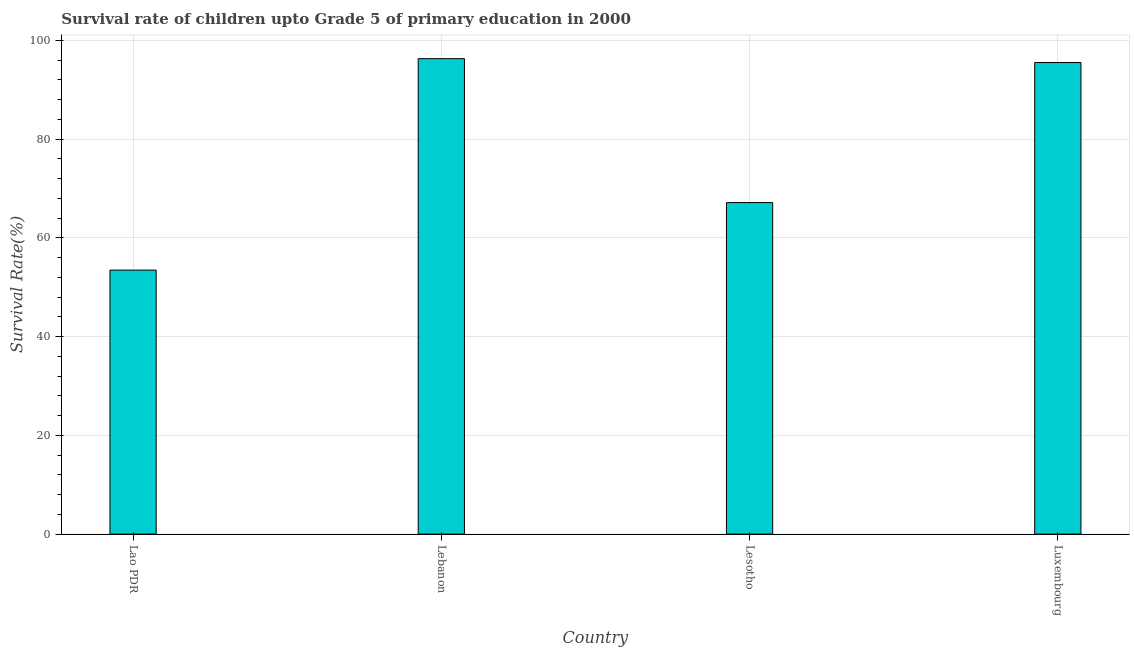Does the graph contain any zero values?
Provide a short and direct response. No. What is the title of the graph?
Provide a succinct answer. Survival rate of children upto Grade 5 of primary education in 2000 . What is the label or title of the X-axis?
Your answer should be very brief. Country. What is the label or title of the Y-axis?
Provide a short and direct response. Survival Rate(%). What is the survival rate in Lebanon?
Give a very brief answer. 96.32. Across all countries, what is the maximum survival rate?
Make the answer very short. 96.32. Across all countries, what is the minimum survival rate?
Offer a very short reply. 53.48. In which country was the survival rate maximum?
Provide a short and direct response. Lebanon. In which country was the survival rate minimum?
Offer a very short reply. Lao PDR. What is the sum of the survival rate?
Ensure brevity in your answer.  312.49. What is the difference between the survival rate in Lao PDR and Lebanon?
Keep it short and to the point. -42.84. What is the average survival rate per country?
Offer a very short reply. 78.12. What is the median survival rate?
Your answer should be very brief. 81.35. In how many countries, is the survival rate greater than 4 %?
Your answer should be compact. 4. What is the ratio of the survival rate in Lao PDR to that in Luxembourg?
Your response must be concise. 0.56. Is the difference between the survival rate in Lao PDR and Luxembourg greater than the difference between any two countries?
Your answer should be compact. No. What is the difference between the highest and the second highest survival rate?
Provide a succinct answer. 0.79. Is the sum of the survival rate in Lesotho and Luxembourg greater than the maximum survival rate across all countries?
Provide a succinct answer. Yes. What is the difference between the highest and the lowest survival rate?
Your response must be concise. 42.84. How many bars are there?
Offer a terse response. 4. Are all the bars in the graph horizontal?
Provide a short and direct response. No. How many countries are there in the graph?
Your answer should be very brief. 4. What is the difference between two consecutive major ticks on the Y-axis?
Your answer should be very brief. 20. Are the values on the major ticks of Y-axis written in scientific E-notation?
Your response must be concise. No. What is the Survival Rate(%) of Lao PDR?
Keep it short and to the point. 53.48. What is the Survival Rate(%) in Lebanon?
Your answer should be very brief. 96.32. What is the Survival Rate(%) in Lesotho?
Your response must be concise. 67.16. What is the Survival Rate(%) of Luxembourg?
Offer a terse response. 95.53. What is the difference between the Survival Rate(%) in Lao PDR and Lebanon?
Make the answer very short. -42.84. What is the difference between the Survival Rate(%) in Lao PDR and Lesotho?
Your answer should be compact. -13.68. What is the difference between the Survival Rate(%) in Lao PDR and Luxembourg?
Give a very brief answer. -42.06. What is the difference between the Survival Rate(%) in Lebanon and Lesotho?
Ensure brevity in your answer.  29.16. What is the difference between the Survival Rate(%) in Lebanon and Luxembourg?
Ensure brevity in your answer.  0.79. What is the difference between the Survival Rate(%) in Lesotho and Luxembourg?
Make the answer very short. -28.37. What is the ratio of the Survival Rate(%) in Lao PDR to that in Lebanon?
Offer a very short reply. 0.56. What is the ratio of the Survival Rate(%) in Lao PDR to that in Lesotho?
Offer a very short reply. 0.8. What is the ratio of the Survival Rate(%) in Lao PDR to that in Luxembourg?
Offer a terse response. 0.56. What is the ratio of the Survival Rate(%) in Lebanon to that in Lesotho?
Offer a very short reply. 1.43. What is the ratio of the Survival Rate(%) in Lesotho to that in Luxembourg?
Keep it short and to the point. 0.7. 